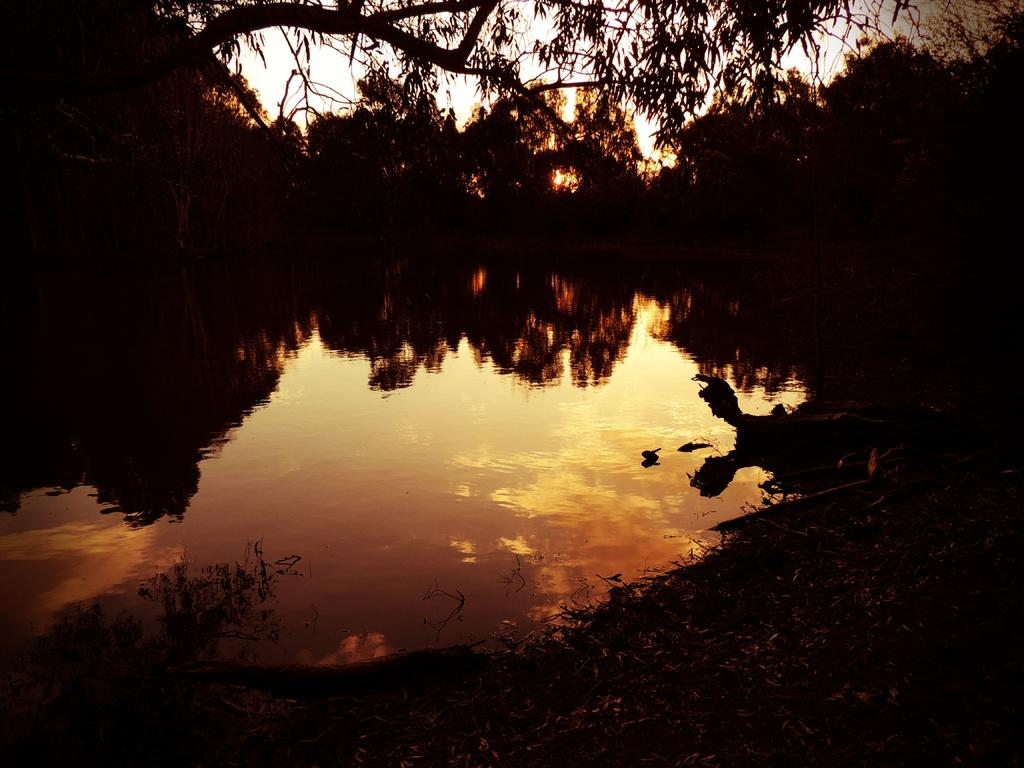What is the overall lighting condition in the image? The image is dark. What natural element can be seen in the image? There is water visible in the image. What type of vegetation is present in the image? There are trees in the image. What is visible in the background of the image? The sky is visible in the image, and clouds are present in the sky. What can be observed on the surface of the water in the image? There is a reflection of trees and sky with clouds on the water. Can you see a snail crawling on the tree in the image? There is no snail visible on the tree in the image. What type of rifle is being used by the person in the image? There is no person or rifle present in the image. 